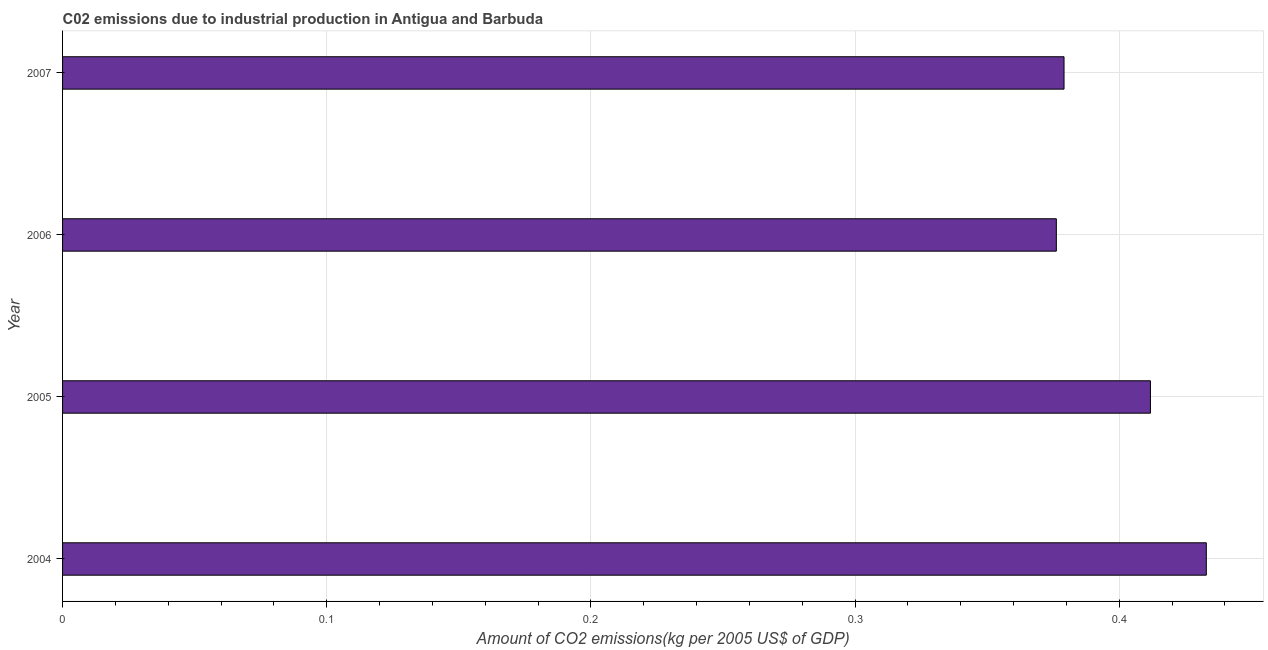Does the graph contain any zero values?
Ensure brevity in your answer.  No. Does the graph contain grids?
Provide a short and direct response. Yes. What is the title of the graph?
Your response must be concise. C02 emissions due to industrial production in Antigua and Barbuda. What is the label or title of the X-axis?
Make the answer very short. Amount of CO2 emissions(kg per 2005 US$ of GDP). What is the amount of co2 emissions in 2006?
Offer a very short reply. 0.38. Across all years, what is the maximum amount of co2 emissions?
Offer a very short reply. 0.43. Across all years, what is the minimum amount of co2 emissions?
Provide a succinct answer. 0.38. What is the sum of the amount of co2 emissions?
Give a very brief answer. 1.6. What is the difference between the amount of co2 emissions in 2005 and 2006?
Offer a very short reply. 0.04. What is the median amount of co2 emissions?
Ensure brevity in your answer.  0.4. In how many years, is the amount of co2 emissions greater than 0.16 kg per 2005 US$ of GDP?
Offer a very short reply. 4. What is the ratio of the amount of co2 emissions in 2004 to that in 2007?
Provide a short and direct response. 1.14. Is the amount of co2 emissions in 2004 less than that in 2005?
Offer a very short reply. No. What is the difference between the highest and the second highest amount of co2 emissions?
Provide a succinct answer. 0.02. Is the sum of the amount of co2 emissions in 2005 and 2006 greater than the maximum amount of co2 emissions across all years?
Offer a very short reply. Yes. What is the difference between the highest and the lowest amount of co2 emissions?
Provide a short and direct response. 0.06. In how many years, is the amount of co2 emissions greater than the average amount of co2 emissions taken over all years?
Make the answer very short. 2. How many bars are there?
Your response must be concise. 4. How many years are there in the graph?
Offer a terse response. 4. What is the difference between two consecutive major ticks on the X-axis?
Your response must be concise. 0.1. What is the Amount of CO2 emissions(kg per 2005 US$ of GDP) of 2004?
Give a very brief answer. 0.43. What is the Amount of CO2 emissions(kg per 2005 US$ of GDP) of 2005?
Provide a short and direct response. 0.41. What is the Amount of CO2 emissions(kg per 2005 US$ of GDP) in 2006?
Make the answer very short. 0.38. What is the Amount of CO2 emissions(kg per 2005 US$ of GDP) in 2007?
Offer a very short reply. 0.38. What is the difference between the Amount of CO2 emissions(kg per 2005 US$ of GDP) in 2004 and 2005?
Provide a succinct answer. 0.02. What is the difference between the Amount of CO2 emissions(kg per 2005 US$ of GDP) in 2004 and 2006?
Your answer should be compact. 0.06. What is the difference between the Amount of CO2 emissions(kg per 2005 US$ of GDP) in 2004 and 2007?
Ensure brevity in your answer.  0.05. What is the difference between the Amount of CO2 emissions(kg per 2005 US$ of GDP) in 2005 and 2006?
Provide a succinct answer. 0.04. What is the difference between the Amount of CO2 emissions(kg per 2005 US$ of GDP) in 2005 and 2007?
Your answer should be very brief. 0.03. What is the difference between the Amount of CO2 emissions(kg per 2005 US$ of GDP) in 2006 and 2007?
Ensure brevity in your answer.  -0. What is the ratio of the Amount of CO2 emissions(kg per 2005 US$ of GDP) in 2004 to that in 2005?
Provide a short and direct response. 1.05. What is the ratio of the Amount of CO2 emissions(kg per 2005 US$ of GDP) in 2004 to that in 2006?
Provide a short and direct response. 1.15. What is the ratio of the Amount of CO2 emissions(kg per 2005 US$ of GDP) in 2004 to that in 2007?
Ensure brevity in your answer.  1.14. What is the ratio of the Amount of CO2 emissions(kg per 2005 US$ of GDP) in 2005 to that in 2006?
Give a very brief answer. 1.09. What is the ratio of the Amount of CO2 emissions(kg per 2005 US$ of GDP) in 2005 to that in 2007?
Offer a very short reply. 1.09. 